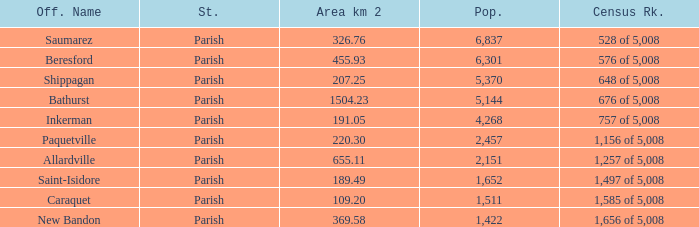What is the Area of the Allardville Parish with a Population smaller than 2,151? None. 